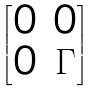<formula> <loc_0><loc_0><loc_500><loc_500>\begin{bmatrix} 0 & 0 \\ 0 & \Gamma \end{bmatrix}</formula> 